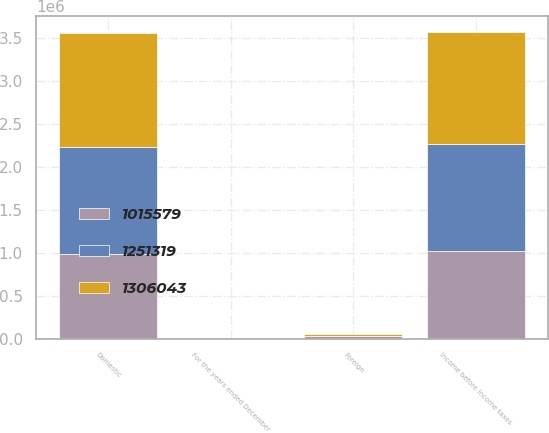<chart> <loc_0><loc_0><loc_500><loc_500><stacked_bar_chart><ecel><fcel>For the years ended December<fcel>Domestic<fcel>Foreign<fcel>Income before income taxes<nl><fcel>1.30604e+06<fcel>2014<fcel>1.32074e+06<fcel>14695<fcel>1.30604e+06<nl><fcel>1.25132e+06<fcel>2013<fcel>1.25221e+06<fcel>889<fcel>1.25132e+06<nl><fcel>1.01558e+06<fcel>2012<fcel>980176<fcel>35403<fcel>1.01558e+06<nl></chart> 